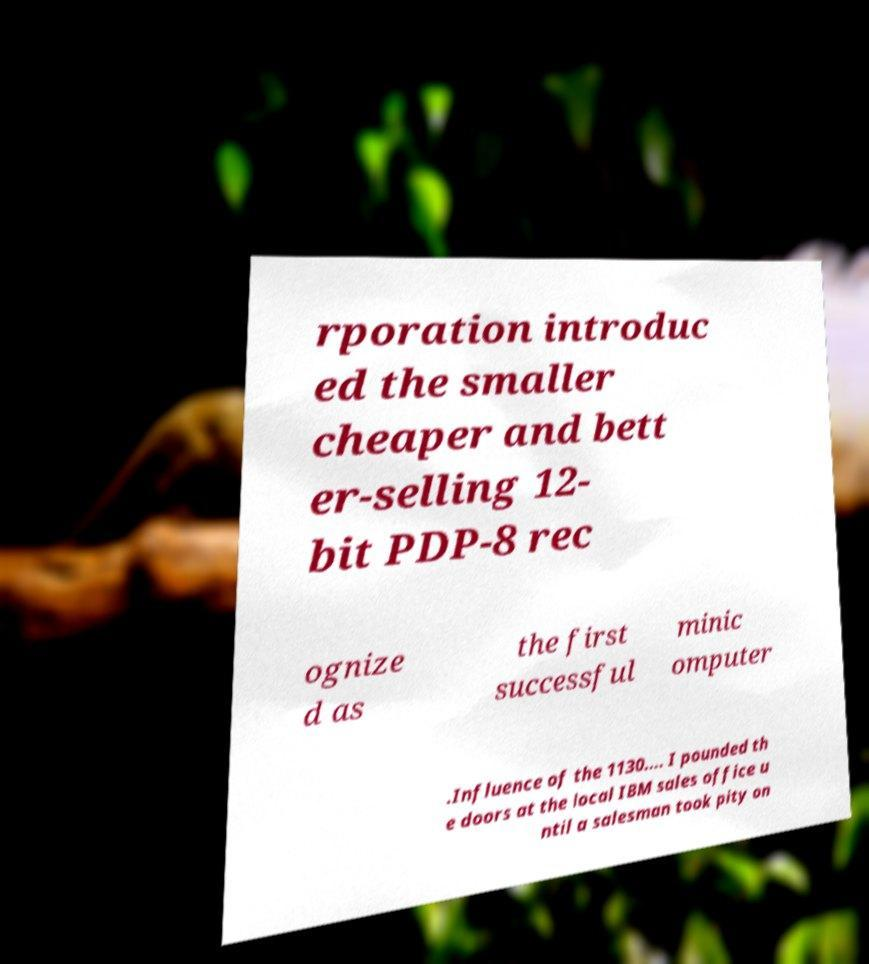For documentation purposes, I need the text within this image transcribed. Could you provide that? rporation introduc ed the smaller cheaper and bett er-selling 12- bit PDP-8 rec ognize d as the first successful minic omputer .Influence of the 1130.... I pounded th e doors at the local IBM sales office u ntil a salesman took pity on 